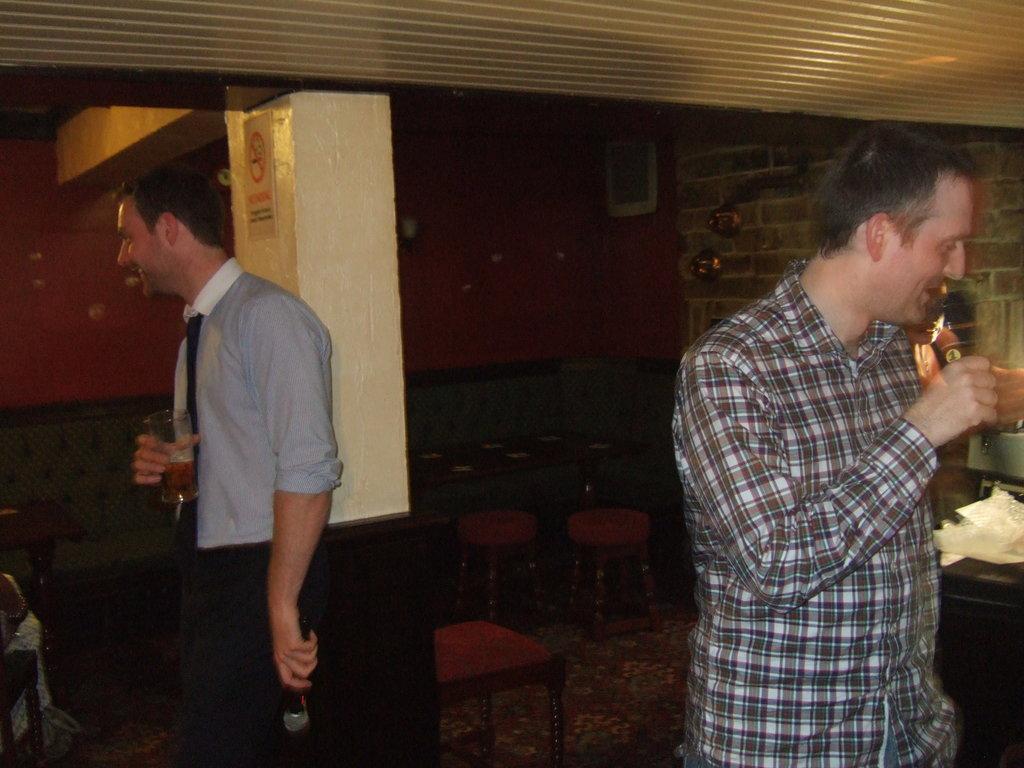Could you give a brief overview of what you see in this image? In the picture there are two men,first man is drinking a drink his holding something in his hand it looks like a mike,the second person is standing and talking,behind them there are some tables and chairs it might be a restaurant there is a pillar in between,in the background there is a red color wall and photo frame the wall,to the right side there is a brick wall. 